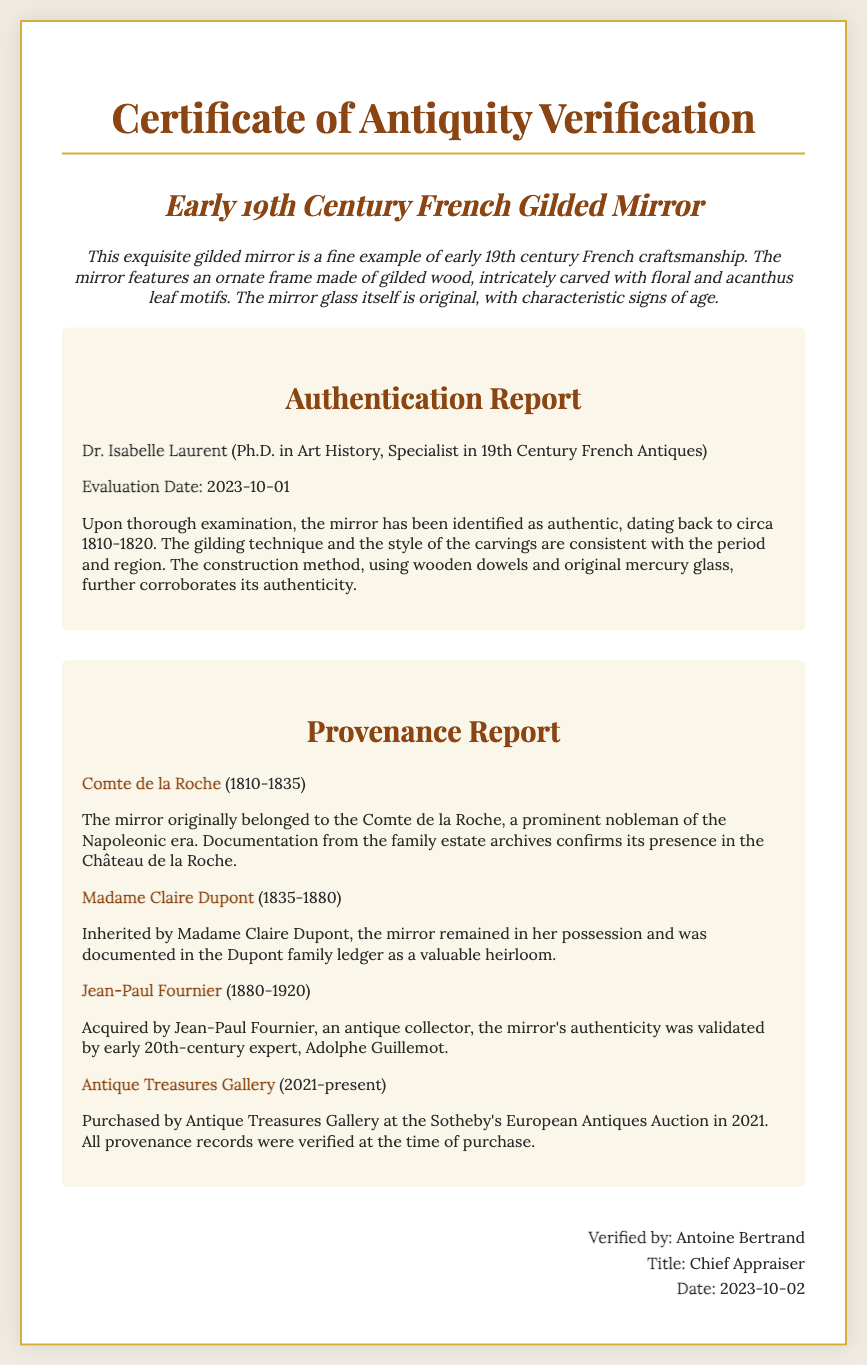What is the title of the document? The title is presented at the top of the rendered certificate.
Answer: Certificate of Antiquity Verification Who is the expert that authenticated the mirror? The expert's name is clearly mentioned in the Authentication Report section of the document.
Answer: Dr. Isabelle Laurent What year was the mirror evaluated for authenticity? The evaluation date is specified within the Authentication Report section.
Answer: 2023-10-01 What is the original owner of the mirror? The provenance section lists the first owner of the mirror.
Answer: Comte de la Roche What years did Madame Claire Dupont own the mirror? The document indicates the range of years in the provenance section.
Answer: 1835-1880 What appraisal title does Antoine Bertrand hold? The title is stated in the signature section at the bottom of the document.
Answer: Chief Appraiser How was the mirror's authenticity validated in the early 20th century? The document provides details about the validation process from the past.
Answer: Adolphe Guillemot What type of glass is mentioned as original in the mirror? The document specifies the glass type used in the mirror's construction.
Answer: mercury glass What auction house was involved in the mirror's sale in 2021? The provenance report reveals the auction house’s name during the transaction.
Answer: Sotheby's European Antiques Auction 